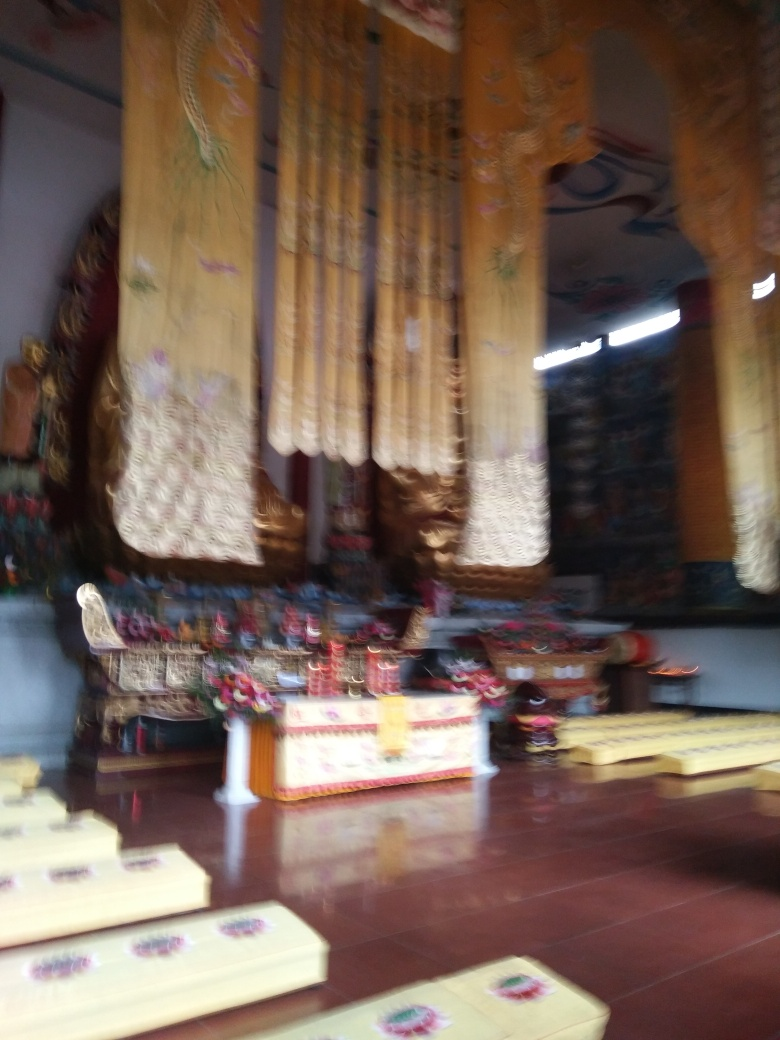Can you describe the general setting of this image? The image seems to capture an interior space, likely a temple or a place of worship, indicated by the ornate curtains and the ceremonial decor. There are several seats or platforms laid out in rows, possibly for participants or observers of a religious ceremony. 